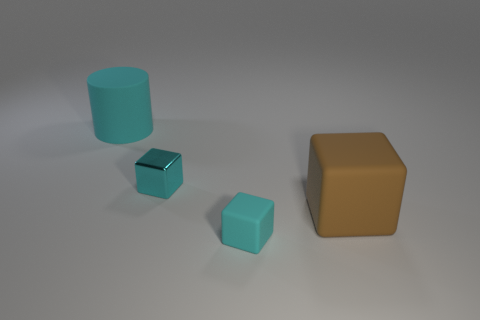Add 2 cubes. How many objects exist? 6 Subtract all cylinders. How many objects are left? 3 Subtract 0 brown cylinders. How many objects are left? 4 Subtract all tiny cyan matte objects. Subtract all tiny metal blocks. How many objects are left? 2 Add 4 matte blocks. How many matte blocks are left? 6 Add 1 cyan rubber cylinders. How many cyan rubber cylinders exist? 2 